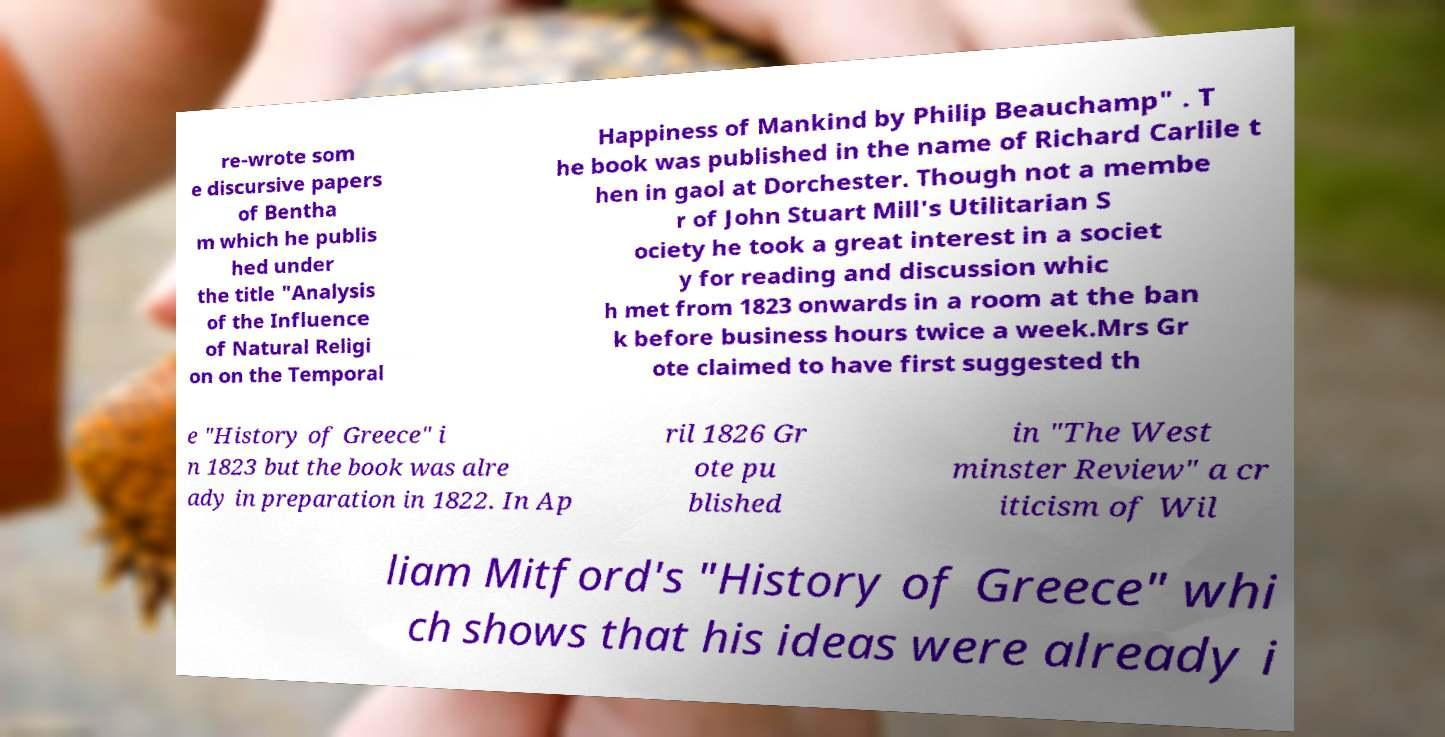For documentation purposes, I need the text within this image transcribed. Could you provide that? re-wrote som e discursive papers of Bentha m which he publis hed under the title "Analysis of the Influence of Natural Religi on on the Temporal Happiness of Mankind by Philip Beauchamp" . T he book was published in the name of Richard Carlile t hen in gaol at Dorchester. Though not a membe r of John Stuart Mill's Utilitarian S ociety he took a great interest in a societ y for reading and discussion whic h met from 1823 onwards in a room at the ban k before business hours twice a week.Mrs Gr ote claimed to have first suggested th e "History of Greece" i n 1823 but the book was alre ady in preparation in 1822. In Ap ril 1826 Gr ote pu blished in "The West minster Review" a cr iticism of Wil liam Mitford's "History of Greece" whi ch shows that his ideas were already i 